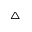Convert formula to latex. <formula><loc_0><loc_0><loc_500><loc_500>^ { \triangle }</formula> 